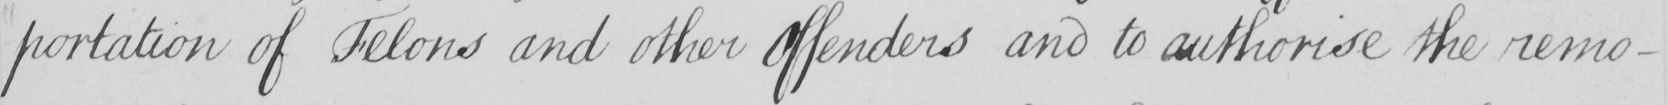Please provide the text content of this handwritten line. -portation of Felons and other Offenders and to authorise the remo- 